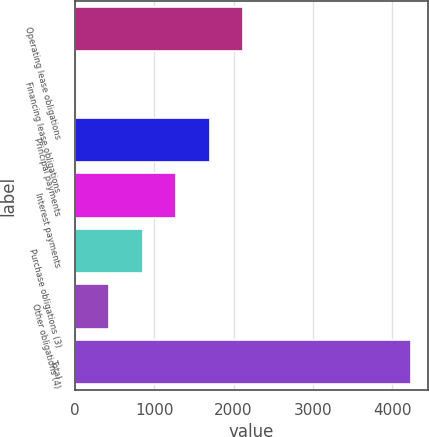<chart> <loc_0><loc_0><loc_500><loc_500><bar_chart><fcel>Operating lease obligations<fcel>Financing lease obligations<fcel>Principal payments<fcel>Interest payments<fcel>Purchase obligations (3)<fcel>Other obligations (4)<fcel>Total<nl><fcel>2124.9<fcel>8.3<fcel>1701.58<fcel>1278.26<fcel>854.94<fcel>431.62<fcel>4241.5<nl></chart> 